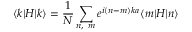Convert formula to latex. <formula><loc_0><loc_0><loc_500><loc_500>\langle k | H | k \rangle = { \frac { 1 } { N } } \sum _ { n , \ m } e ^ { i ( n - m ) k a } \langle m | H | n \rangle</formula> 